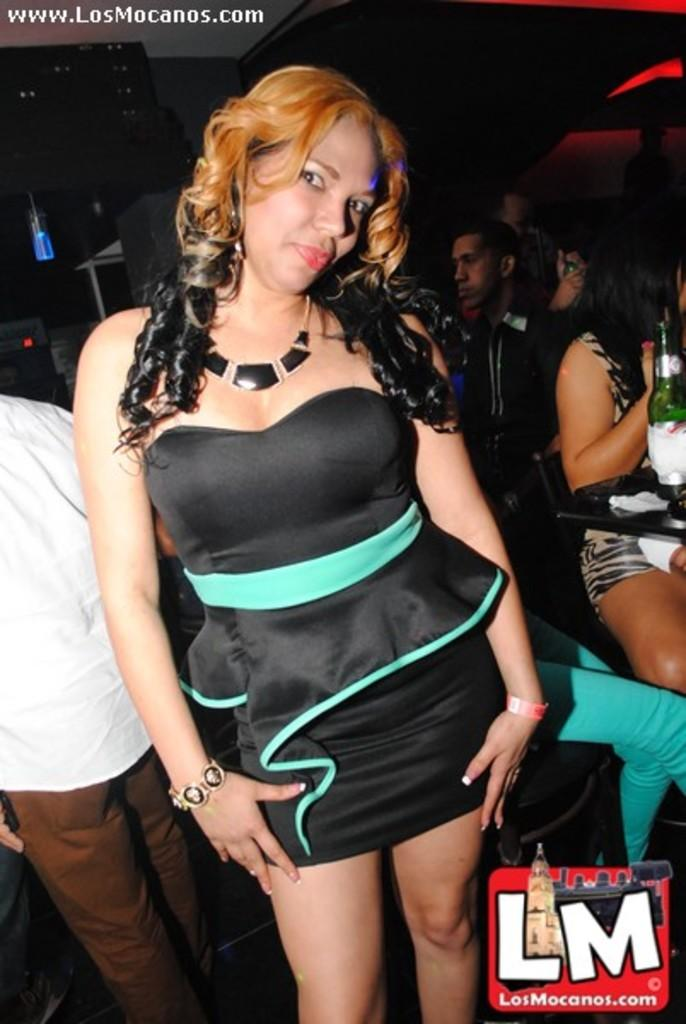<image>
Offer a succinct explanation of the picture presented. A woman in a black dress accented with teal is in a bar with a LM logo and url in the bottom corner. 